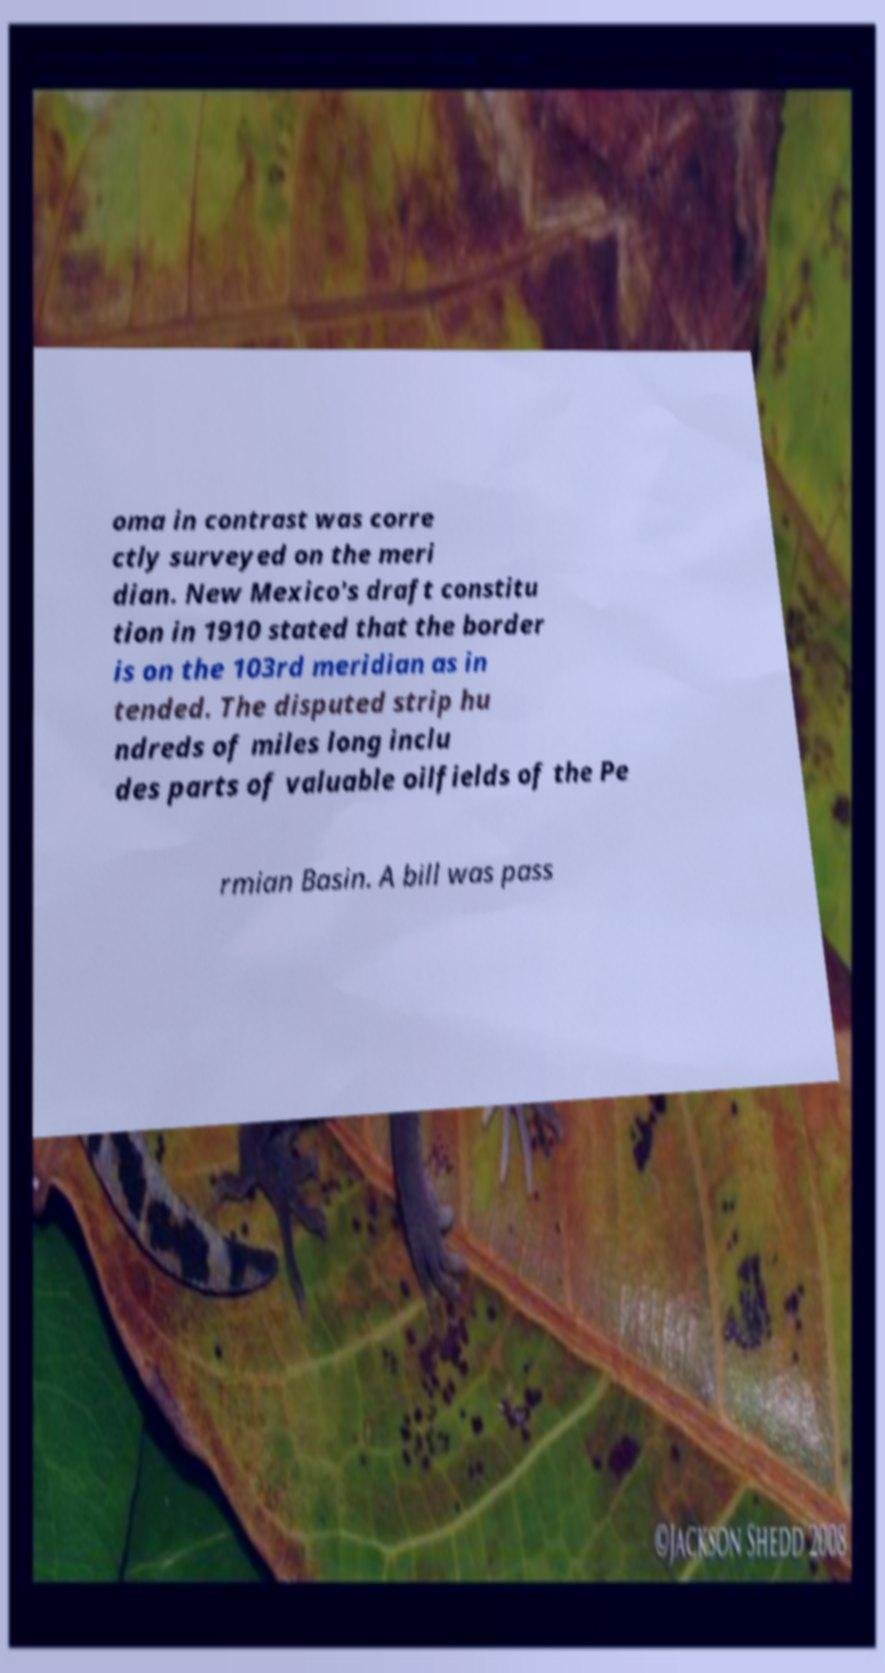Could you extract and type out the text from this image? oma in contrast was corre ctly surveyed on the meri dian. New Mexico's draft constitu tion in 1910 stated that the border is on the 103rd meridian as in tended. The disputed strip hu ndreds of miles long inclu des parts of valuable oilfields of the Pe rmian Basin. A bill was pass 